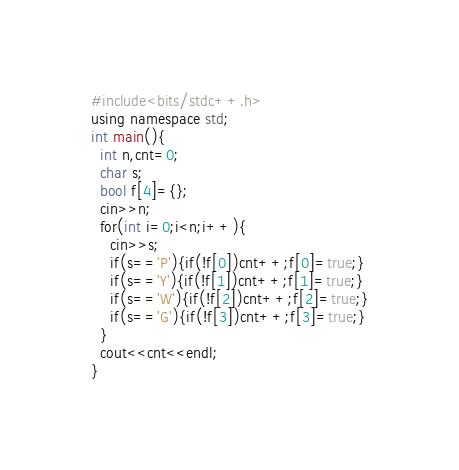<code> <loc_0><loc_0><loc_500><loc_500><_C++_>#include<bits/stdc++.h>
using namespace std;
int main(){
  int n,cnt=0;
  char s;
  bool f[4]={};
  cin>>n;
  for(int i=0;i<n;i++){
    cin>>s;
    if(s=='P'){if(!f[0])cnt++;f[0]=true;}
    if(s=='Y'){if(!f[1])cnt++;f[1]=true;}
    if(s=='W'){if(!f[2])cnt++;f[2]=true;}
    if(s=='G'){if(!f[3])cnt++;f[3]=true;}
  }
  cout<<cnt<<endl;
}</code> 